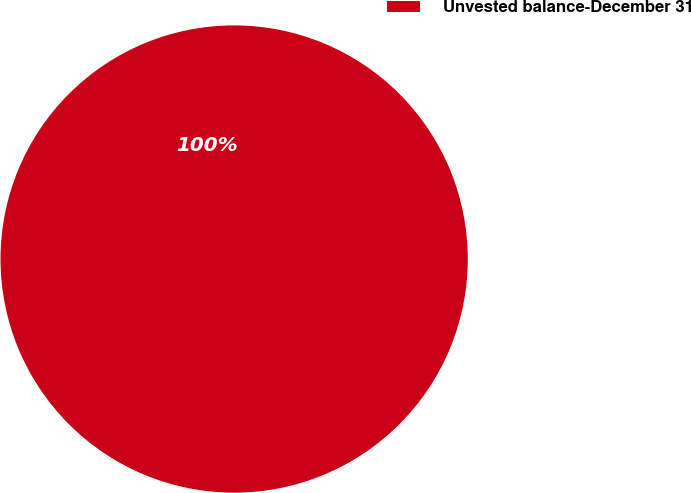Convert chart. <chart><loc_0><loc_0><loc_500><loc_500><pie_chart><fcel>Unvested balance-December 31<nl><fcel>100.0%<nl></chart> 